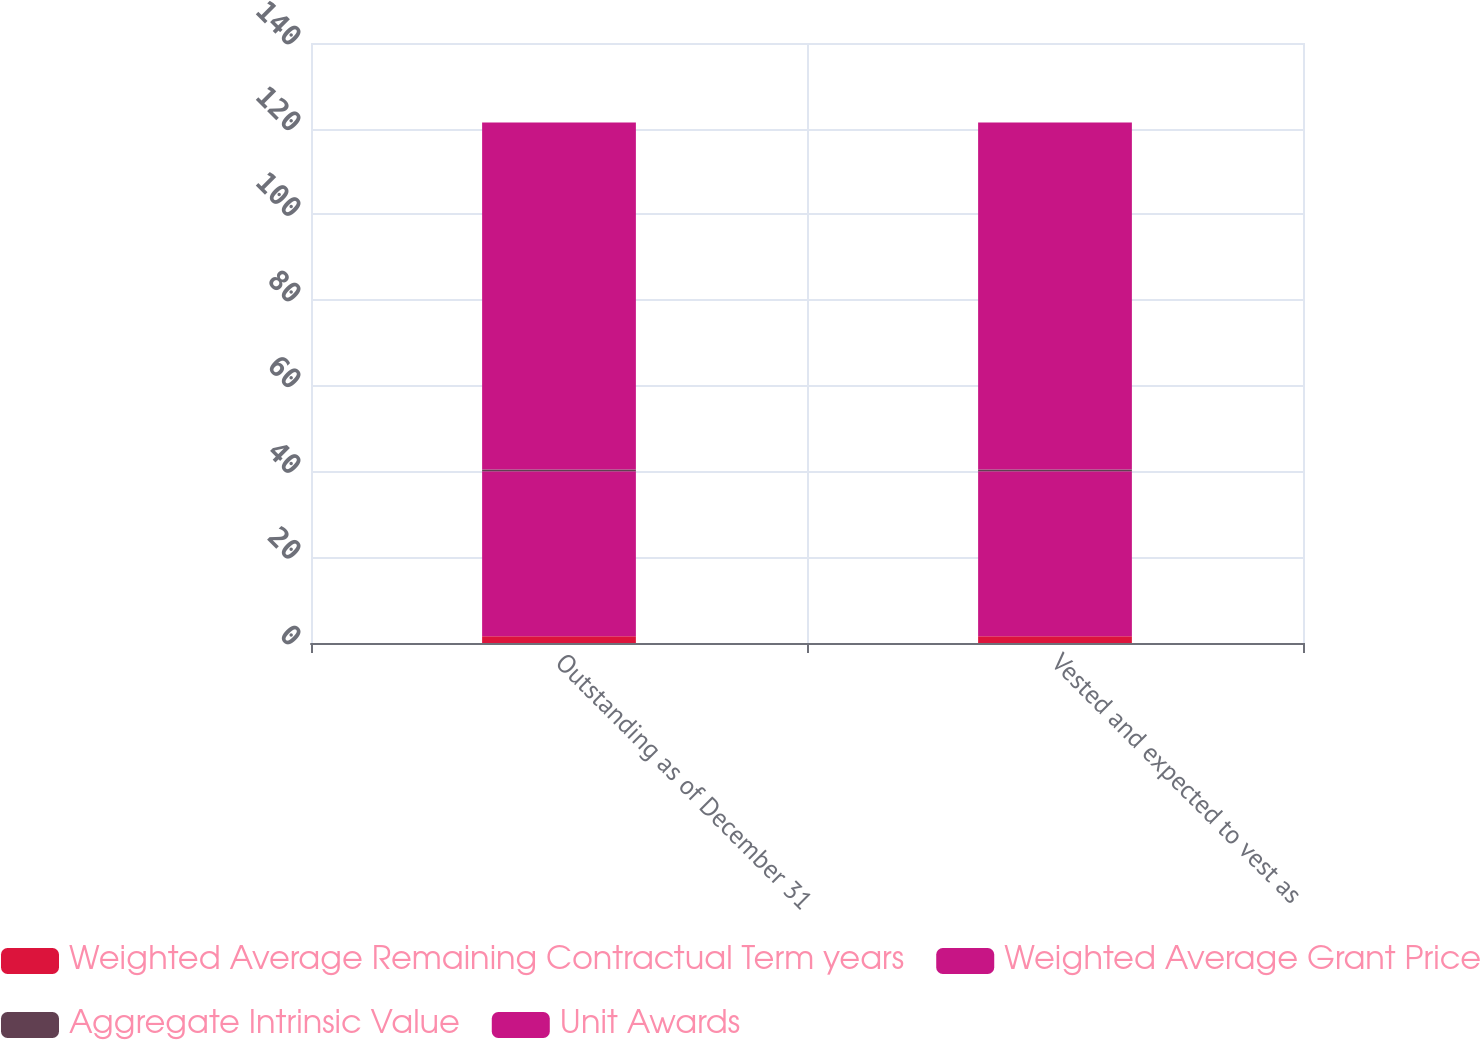<chart> <loc_0><loc_0><loc_500><loc_500><stacked_bar_chart><ecel><fcel>Outstanding as of December 31<fcel>Vested and expected to vest as<nl><fcel>Weighted Average Remaining Contractual Term years<fcel>1.6<fcel>1.6<nl><fcel>Weighted Average Grant Price<fcel>38.46<fcel>38.46<nl><fcel>Aggregate Intrinsic Value<fcel>0.4<fcel>0.4<nl><fcel>Unit Awards<fcel>81<fcel>81<nl></chart> 